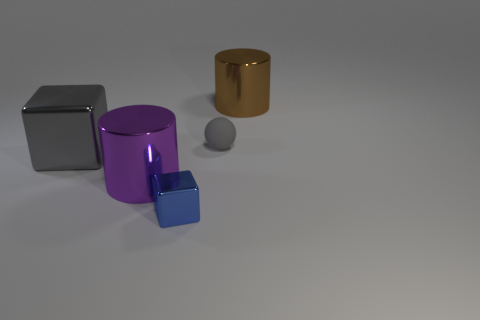Are there any other things that have the same shape as the rubber object?
Keep it short and to the point. No. What number of purple objects are metallic cylinders or cubes?
Your answer should be compact. 1. What is the gray thing left of the blue object made of?
Your answer should be compact. Metal. There is a metal block to the right of the large metallic block; what number of big things are right of it?
Make the answer very short. 1. What number of other big objects have the same shape as the gray matte object?
Offer a very short reply. 0. How many large blue rubber spheres are there?
Make the answer very short. 0. The large thing behind the gray cube is what color?
Offer a very short reply. Brown. There is a large shiny cylinder on the left side of the tiny blue metallic block left of the brown cylinder; what is its color?
Ensure brevity in your answer.  Purple. There is a metal cube that is the same size as the gray rubber sphere; what is its color?
Give a very brief answer. Blue. What number of shiny objects are both in front of the brown metallic cylinder and right of the large gray metallic block?
Offer a very short reply. 2. 